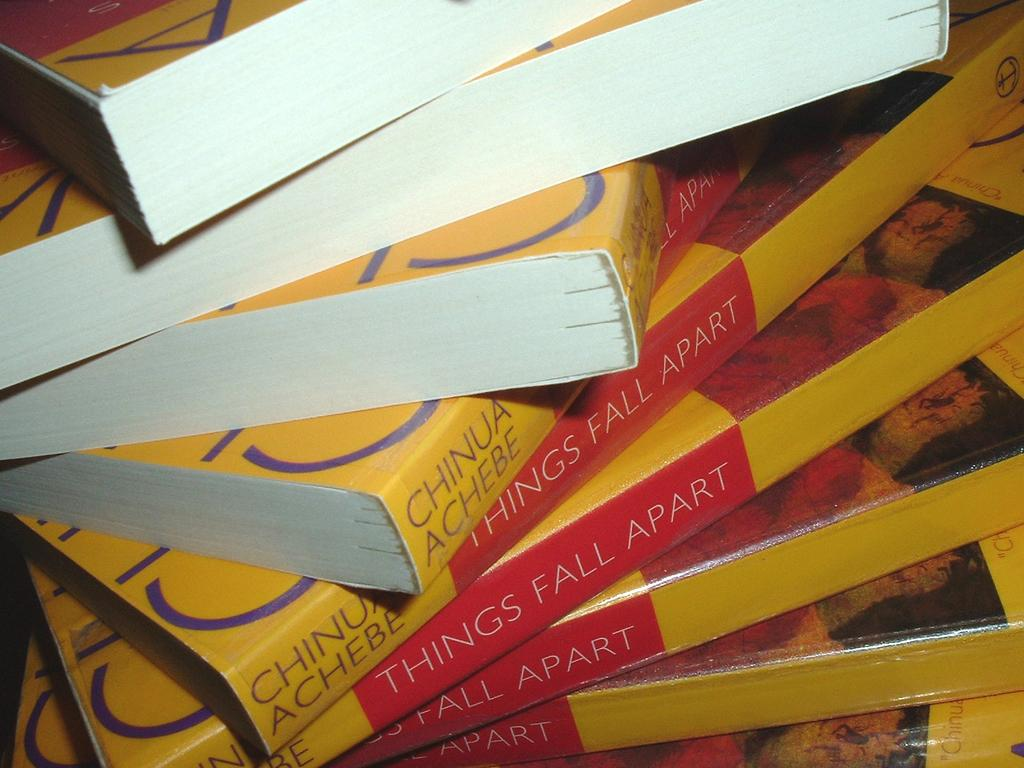<image>
Render a clear and concise summary of the photo. Several copies of Things Fall Apart are artfully stacked on top of each other. 